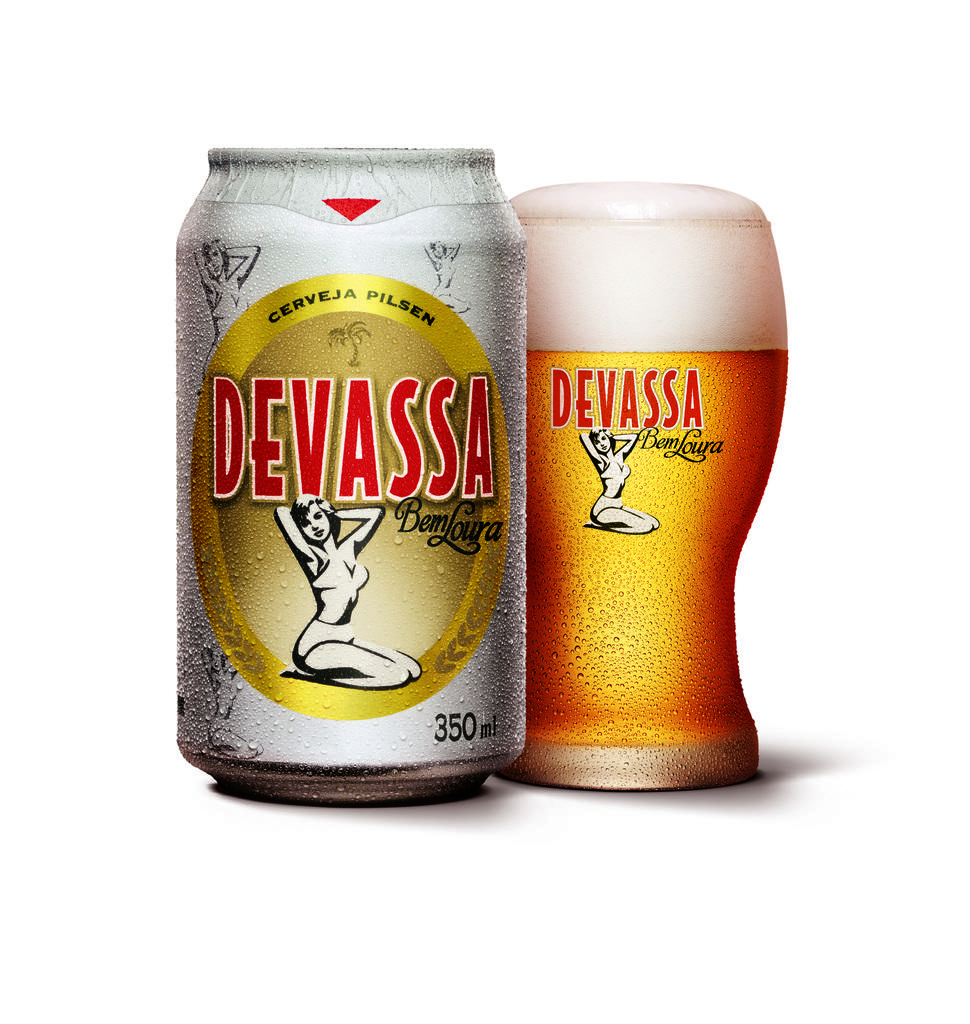What brand is featured?
Your response must be concise. Devassa. 